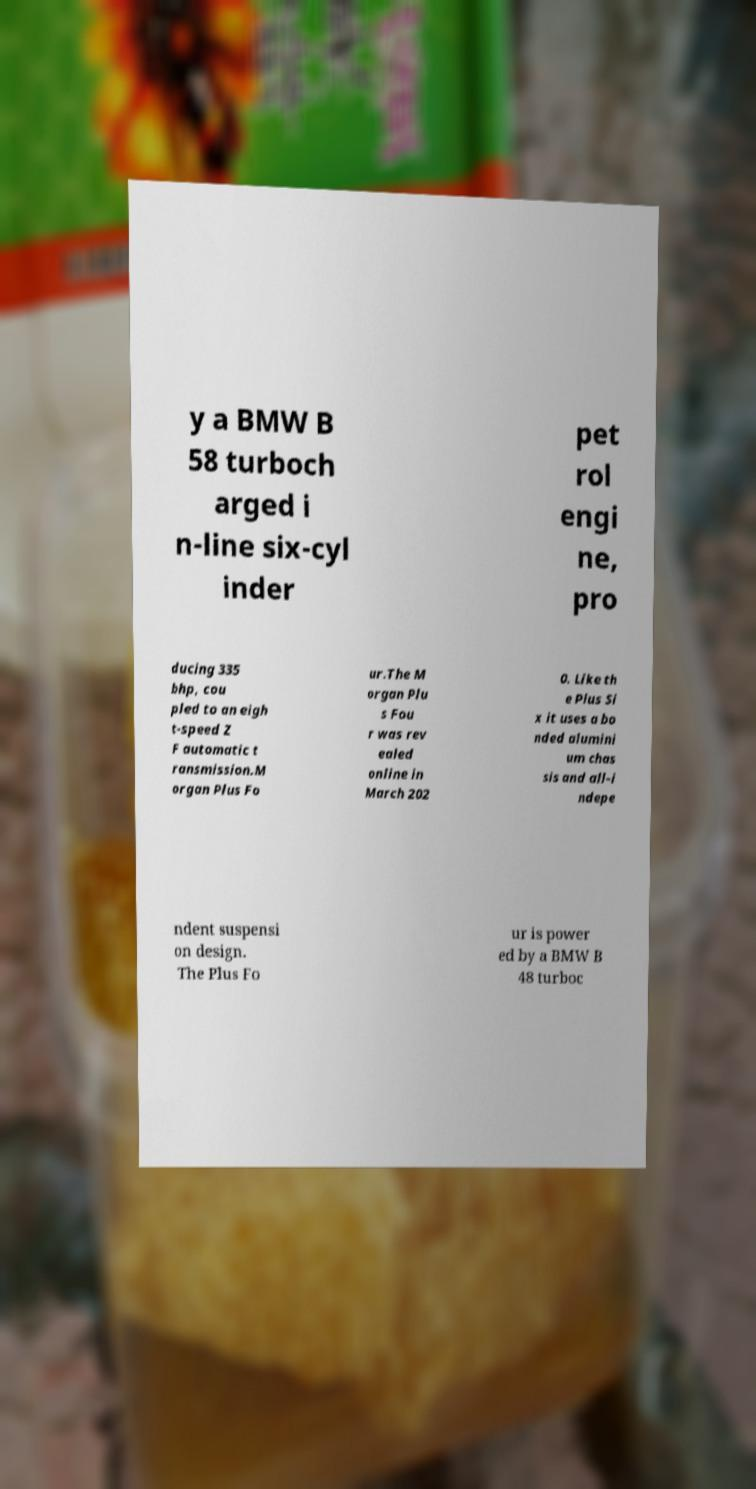What messages or text are displayed in this image? I need them in a readable, typed format. y a BMW B 58 turboch arged i n-line six-cyl inder pet rol engi ne, pro ducing 335 bhp, cou pled to an eigh t-speed Z F automatic t ransmission.M organ Plus Fo ur.The M organ Plu s Fou r was rev ealed online in March 202 0. Like th e Plus Si x it uses a bo nded alumini um chas sis and all-i ndepe ndent suspensi on design. The Plus Fo ur is power ed by a BMW B 48 turboc 